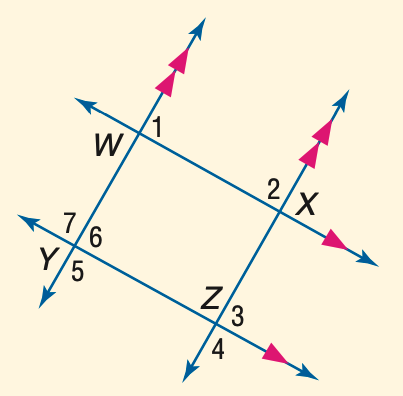Answer the mathemtical geometry problem and directly provide the correct option letter.
Question: In the figure, m \angle 1 = 53. Find the measure of \angle 6.
Choices: A: 53 B: 57 C: 63 D: 67 A 